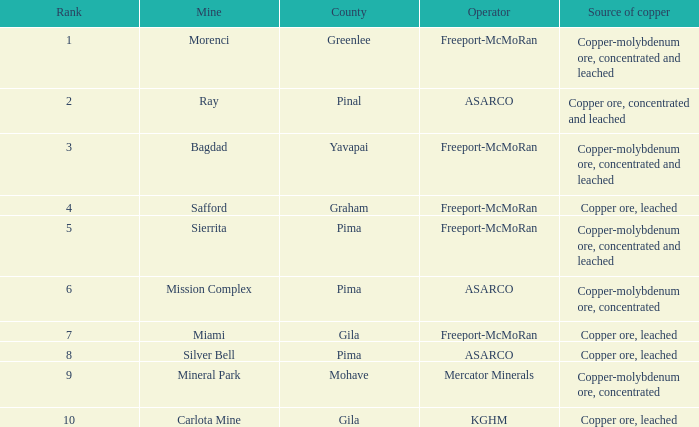What's the name of the operator who has the mission complex mine and has a 2012 Cu Production (lbs) larger than 23.3? ASARCO. 